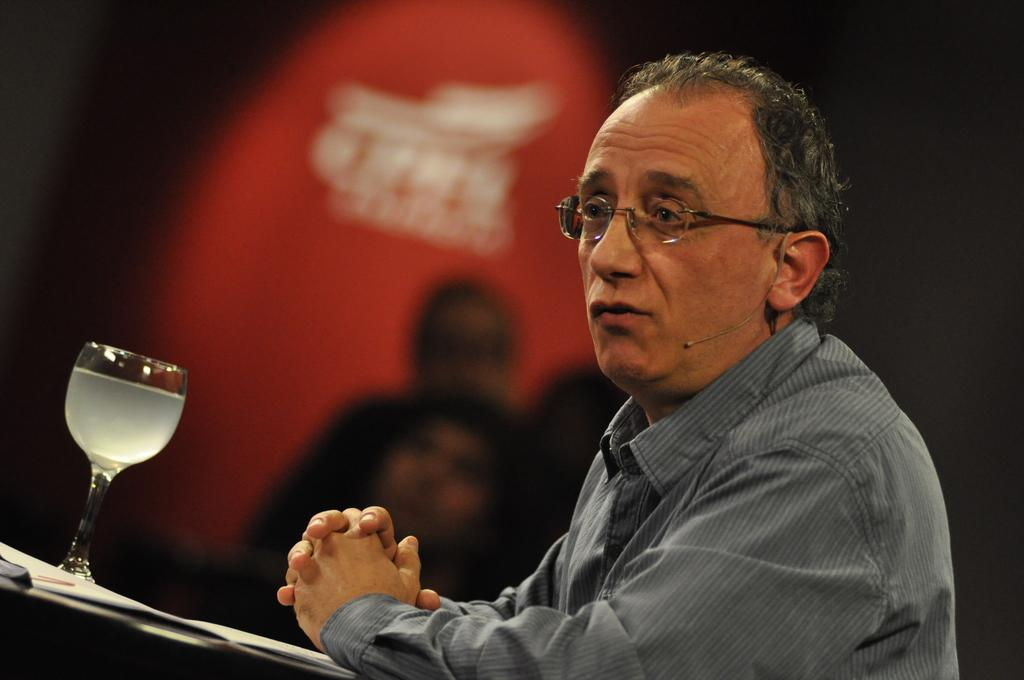What is the person in the image wearing on their face? The person in the image is wearing specs. What type of clothing is the person wearing on their upper body? The person is wearing a shirt. What is the person standing in front of in the image? The person is standing before a table. What can be seen on the table in the image? There is a glass on the table. What can be seen in the background of the image? There are people visible in the background of the image. How does the rabbit feel about the person in the image? There is no rabbit present in the image, so it is not possible to determine how a rabbit might feel about the person. 